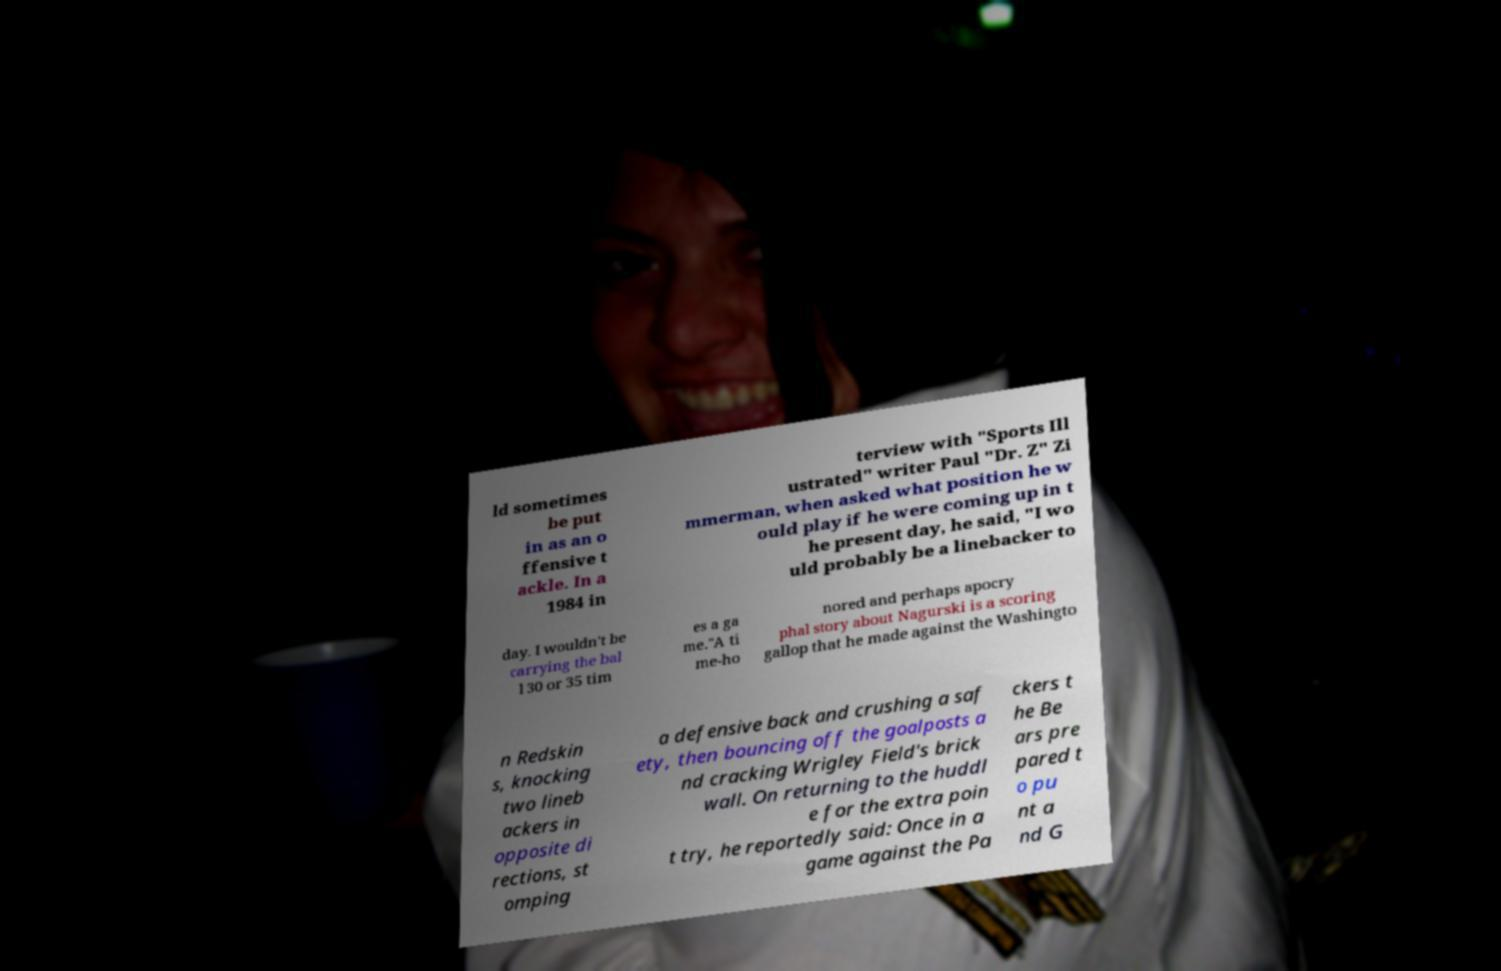Could you assist in decoding the text presented in this image and type it out clearly? ld sometimes be put in as an o ffensive t ackle. In a 1984 in terview with "Sports Ill ustrated" writer Paul "Dr. Z" Zi mmerman, when asked what position he w ould play if he were coming up in t he present day, he said, "I wo uld probably be a linebacker to day. I wouldn't be carrying the bal l 30 or 35 tim es a ga me."A ti me-ho nored and perhaps apocry phal story about Nagurski is a scoring gallop that he made against the Washingto n Redskin s, knocking two lineb ackers in opposite di rections, st omping a defensive back and crushing a saf ety, then bouncing off the goalposts a nd cracking Wrigley Field's brick wall. On returning to the huddl e for the extra poin t try, he reportedly said: Once in a game against the Pa ckers t he Be ars pre pared t o pu nt a nd G 